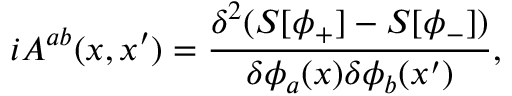Convert formula to latex. <formula><loc_0><loc_0><loc_500><loc_500>i A ^ { a b } ( x , x ^ { \prime } ) = \frac { \delta ^ { 2 } ( S [ \phi _ { + } ] - S [ \phi _ { - } ] ) } { \delta \phi _ { a } ( x ) \delta \phi _ { b } ( x ^ { \prime } ) } ,</formula> 